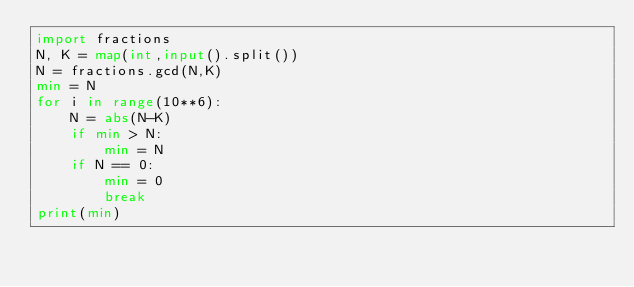<code> <loc_0><loc_0><loc_500><loc_500><_Python_>import fractions
N, K = map(int,input().split())
N = fractions.gcd(N,K)
min = N
for i in range(10**6):
    N = abs(N-K)
    if min > N:
        min = N
    if N == 0:
        min = 0
        break
print(min)</code> 